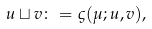Convert formula to latex. <formula><loc_0><loc_0><loc_500><loc_500>u \sqcup v \colon = \varsigma ( \mu ; u , v ) ,</formula> 